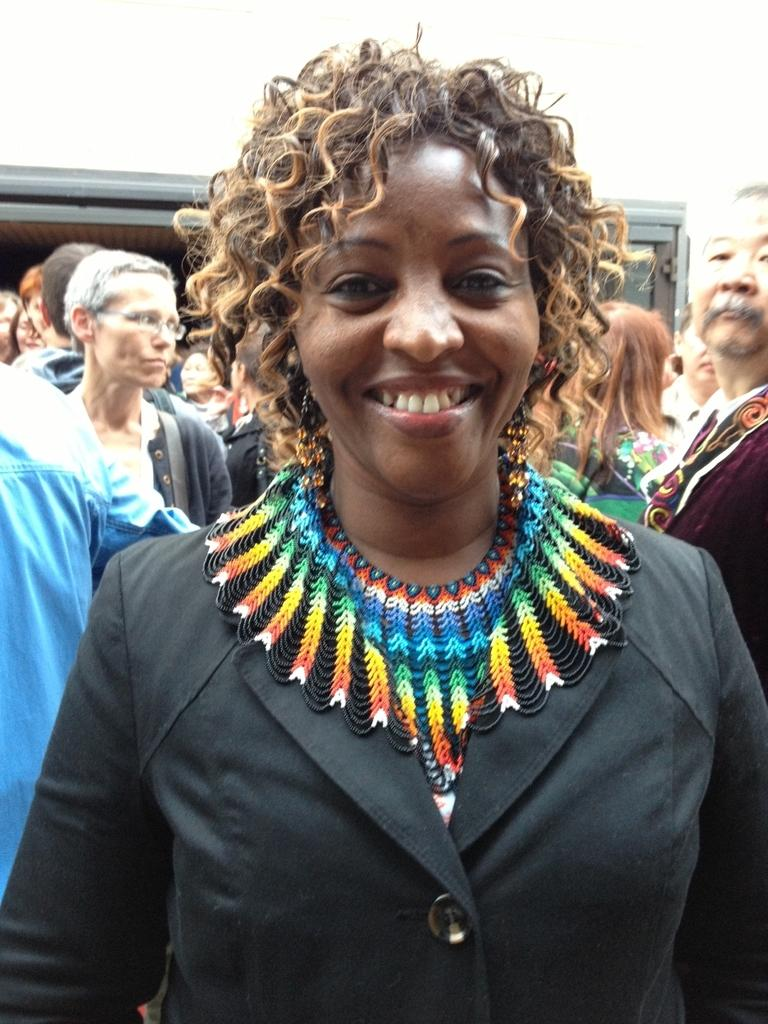Who is the main subject in the foreground of the image? There is a woman in the foreground of the image. What is the woman wearing? The woman is wearing a black coat. What is the woman's facial expression in the image? The woman is smiling. What can be seen in the background of the image? There are persons and a wall in the background of the image. Can you see the ocean in the background of the image? No, there is no ocean visible in the image; it features a woman in the foreground and persons and a wall in the background. 